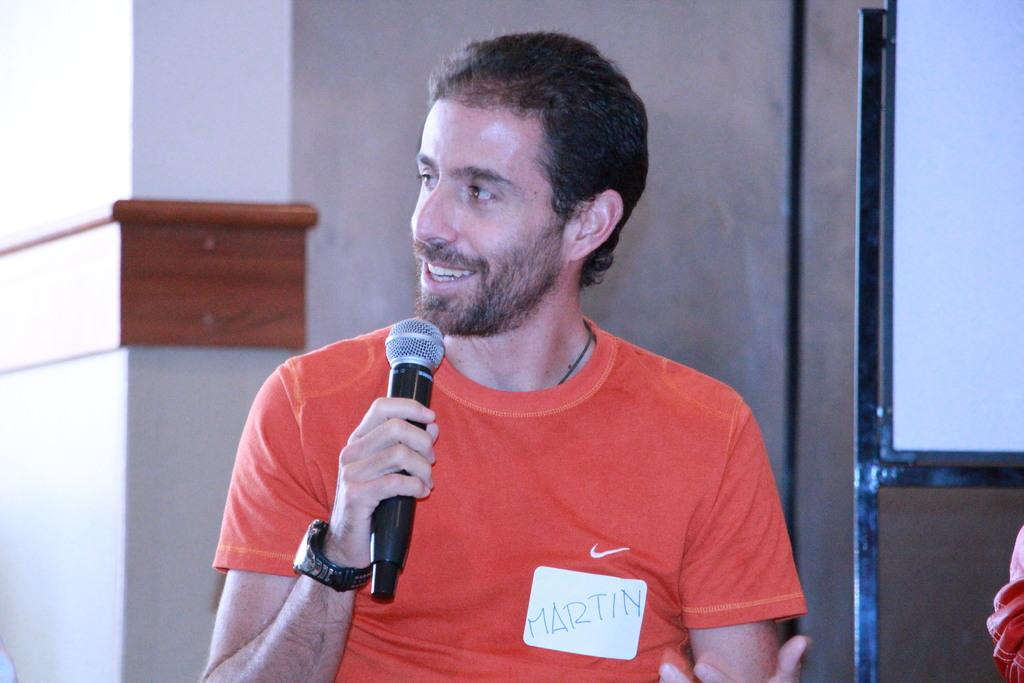What can be seen in the image? There is a person in the image. What is the person holding? The person is holding something. What is located beside the person? There is a board beside the person. What can be seen in the background of the image? There is a wall in the background of the image. How many snails can be seen on the board in the image? There are no snails present in the image. What type of apples are being tasted by the person in the image? There is no indication that the person is tasting apples or any other food in the image. 